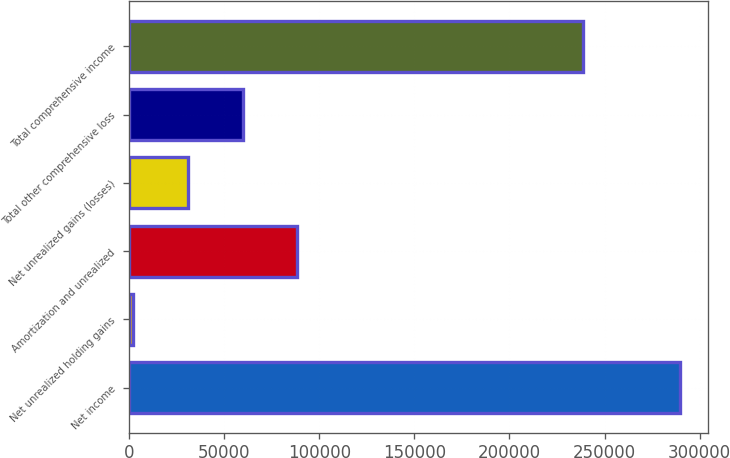<chart> <loc_0><loc_0><loc_500><loc_500><bar_chart><fcel>Net income<fcel>Net unrealized holding gains<fcel>Amortization and unrealized<fcel>Net unrealized gains (losses)<fcel>Total other comprehensive loss<fcel>Total comprehensive income<nl><fcel>289817<fcel>2214<fcel>88494.9<fcel>30974.3<fcel>59734.6<fcel>238546<nl></chart> 